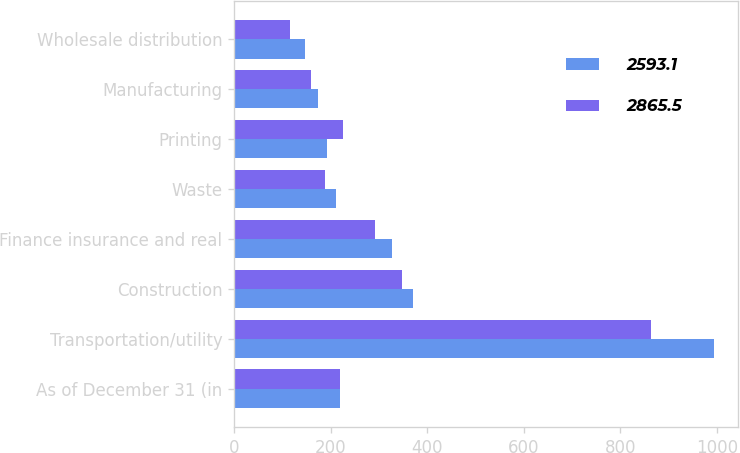<chart> <loc_0><loc_0><loc_500><loc_500><stacked_bar_chart><ecel><fcel>As of December 31 (in<fcel>Transportation/utility<fcel>Construction<fcel>Finance insurance and real<fcel>Waste<fcel>Printing<fcel>Manufacturing<fcel>Wholesale distribution<nl><fcel>2593.1<fcel>219.1<fcel>994.8<fcel>371.4<fcel>328.3<fcel>211.8<fcel>192.5<fcel>174.9<fcel>146.8<nl><fcel>2865.5<fcel>219.1<fcel>864.5<fcel>348.4<fcel>292.5<fcel>187.9<fcel>226.4<fcel>159.4<fcel>117.1<nl></chart> 